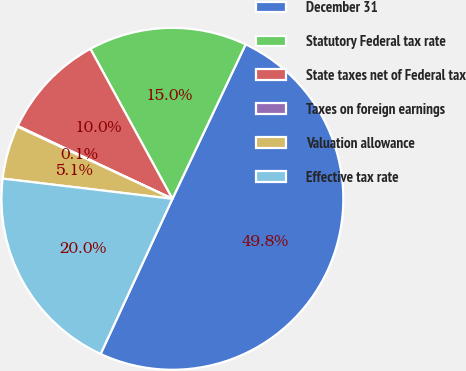<chart> <loc_0><loc_0><loc_500><loc_500><pie_chart><fcel>December 31<fcel>Statutory Federal tax rate<fcel>State taxes net of Federal tax<fcel>Taxes on foreign earnings<fcel>Valuation allowance<fcel>Effective tax rate<nl><fcel>49.85%<fcel>15.01%<fcel>10.03%<fcel>0.07%<fcel>5.05%<fcel>19.99%<nl></chart> 